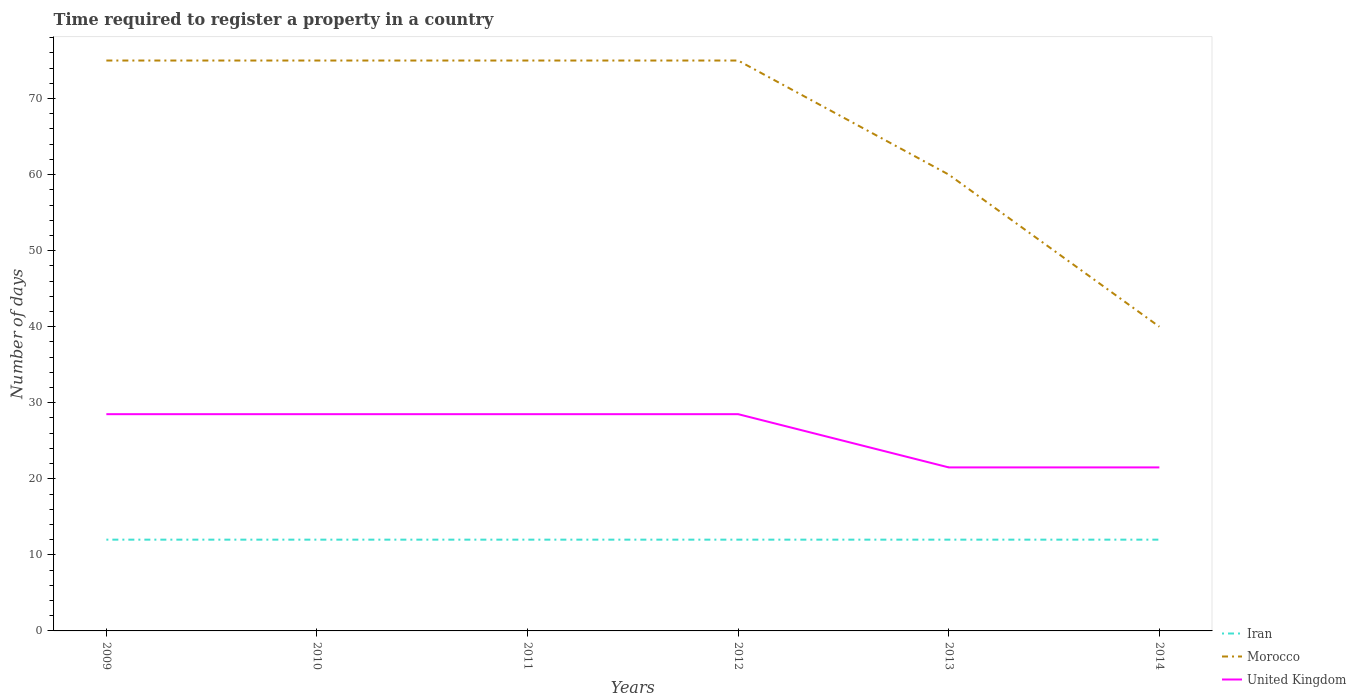How many different coloured lines are there?
Your answer should be compact. 3. Does the line corresponding to Iran intersect with the line corresponding to United Kingdom?
Ensure brevity in your answer.  No. Is the number of lines equal to the number of legend labels?
Your response must be concise. Yes. Across all years, what is the maximum number of days required to register a property in United Kingdom?
Keep it short and to the point. 21.5. In which year was the number of days required to register a property in Iran maximum?
Keep it short and to the point. 2009. What is the difference between the highest and the second highest number of days required to register a property in Morocco?
Offer a very short reply. 35. What is the difference between the highest and the lowest number of days required to register a property in Iran?
Offer a terse response. 0. How many years are there in the graph?
Your answer should be compact. 6. What is the difference between two consecutive major ticks on the Y-axis?
Make the answer very short. 10. Are the values on the major ticks of Y-axis written in scientific E-notation?
Offer a very short reply. No. Does the graph contain any zero values?
Keep it short and to the point. No. Does the graph contain grids?
Provide a short and direct response. No. What is the title of the graph?
Provide a succinct answer. Time required to register a property in a country. Does "Somalia" appear as one of the legend labels in the graph?
Offer a very short reply. No. What is the label or title of the X-axis?
Keep it short and to the point. Years. What is the label or title of the Y-axis?
Keep it short and to the point. Number of days. What is the Number of days in Morocco in 2009?
Your answer should be compact. 75. What is the Number of days in United Kingdom in 2009?
Your response must be concise. 28.5. What is the Number of days of Iran in 2010?
Make the answer very short. 12. What is the Number of days in Morocco in 2010?
Give a very brief answer. 75. What is the Number of days in United Kingdom in 2010?
Give a very brief answer. 28.5. What is the Number of days of United Kingdom in 2011?
Your response must be concise. 28.5. What is the Number of days of Iran in 2012?
Make the answer very short. 12. What is the Number of days in Morocco in 2012?
Your response must be concise. 75. What is the Number of days of Iran in 2013?
Your response must be concise. 12. What is the Number of days of United Kingdom in 2013?
Give a very brief answer. 21.5. Across all years, what is the maximum Number of days of Iran?
Keep it short and to the point. 12. What is the total Number of days of Iran in the graph?
Your answer should be very brief. 72. What is the total Number of days in Morocco in the graph?
Your answer should be very brief. 400. What is the total Number of days in United Kingdom in the graph?
Keep it short and to the point. 157. What is the difference between the Number of days in Iran in 2009 and that in 2010?
Your response must be concise. 0. What is the difference between the Number of days of United Kingdom in 2009 and that in 2010?
Offer a terse response. 0. What is the difference between the Number of days of Morocco in 2009 and that in 2011?
Give a very brief answer. 0. What is the difference between the Number of days in Morocco in 2009 and that in 2012?
Give a very brief answer. 0. What is the difference between the Number of days of Morocco in 2009 and that in 2013?
Ensure brevity in your answer.  15. What is the difference between the Number of days in Iran in 2009 and that in 2014?
Provide a short and direct response. 0. What is the difference between the Number of days in Morocco in 2009 and that in 2014?
Offer a terse response. 35. What is the difference between the Number of days in United Kingdom in 2009 and that in 2014?
Keep it short and to the point. 7. What is the difference between the Number of days in United Kingdom in 2010 and that in 2011?
Ensure brevity in your answer.  0. What is the difference between the Number of days in Iran in 2010 and that in 2012?
Offer a terse response. 0. What is the difference between the Number of days of Morocco in 2010 and that in 2012?
Provide a succinct answer. 0. What is the difference between the Number of days in United Kingdom in 2010 and that in 2014?
Offer a very short reply. 7. What is the difference between the Number of days of Morocco in 2011 and that in 2012?
Make the answer very short. 0. What is the difference between the Number of days in Iran in 2011 and that in 2013?
Your response must be concise. 0. What is the difference between the Number of days of Morocco in 2011 and that in 2014?
Provide a short and direct response. 35. What is the difference between the Number of days of United Kingdom in 2011 and that in 2014?
Offer a very short reply. 7. What is the difference between the Number of days of Morocco in 2012 and that in 2013?
Offer a terse response. 15. What is the difference between the Number of days in United Kingdom in 2012 and that in 2013?
Give a very brief answer. 7. What is the difference between the Number of days of Iran in 2012 and that in 2014?
Give a very brief answer. 0. What is the difference between the Number of days in Morocco in 2012 and that in 2014?
Your response must be concise. 35. What is the difference between the Number of days in United Kingdom in 2012 and that in 2014?
Your answer should be compact. 7. What is the difference between the Number of days of United Kingdom in 2013 and that in 2014?
Offer a terse response. 0. What is the difference between the Number of days of Iran in 2009 and the Number of days of Morocco in 2010?
Make the answer very short. -63. What is the difference between the Number of days of Iran in 2009 and the Number of days of United Kingdom in 2010?
Ensure brevity in your answer.  -16.5. What is the difference between the Number of days in Morocco in 2009 and the Number of days in United Kingdom in 2010?
Your response must be concise. 46.5. What is the difference between the Number of days in Iran in 2009 and the Number of days in Morocco in 2011?
Make the answer very short. -63. What is the difference between the Number of days in Iran in 2009 and the Number of days in United Kingdom in 2011?
Ensure brevity in your answer.  -16.5. What is the difference between the Number of days in Morocco in 2009 and the Number of days in United Kingdom in 2011?
Your answer should be very brief. 46.5. What is the difference between the Number of days of Iran in 2009 and the Number of days of Morocco in 2012?
Ensure brevity in your answer.  -63. What is the difference between the Number of days in Iran in 2009 and the Number of days in United Kingdom in 2012?
Provide a short and direct response. -16.5. What is the difference between the Number of days of Morocco in 2009 and the Number of days of United Kingdom in 2012?
Your answer should be very brief. 46.5. What is the difference between the Number of days of Iran in 2009 and the Number of days of Morocco in 2013?
Your response must be concise. -48. What is the difference between the Number of days of Morocco in 2009 and the Number of days of United Kingdom in 2013?
Keep it short and to the point. 53.5. What is the difference between the Number of days in Morocco in 2009 and the Number of days in United Kingdom in 2014?
Keep it short and to the point. 53.5. What is the difference between the Number of days in Iran in 2010 and the Number of days in Morocco in 2011?
Your response must be concise. -63. What is the difference between the Number of days of Iran in 2010 and the Number of days of United Kingdom in 2011?
Your response must be concise. -16.5. What is the difference between the Number of days in Morocco in 2010 and the Number of days in United Kingdom in 2011?
Make the answer very short. 46.5. What is the difference between the Number of days in Iran in 2010 and the Number of days in Morocco in 2012?
Give a very brief answer. -63. What is the difference between the Number of days of Iran in 2010 and the Number of days of United Kingdom in 2012?
Give a very brief answer. -16.5. What is the difference between the Number of days in Morocco in 2010 and the Number of days in United Kingdom in 2012?
Provide a succinct answer. 46.5. What is the difference between the Number of days of Iran in 2010 and the Number of days of Morocco in 2013?
Offer a very short reply. -48. What is the difference between the Number of days of Iran in 2010 and the Number of days of United Kingdom in 2013?
Provide a succinct answer. -9.5. What is the difference between the Number of days of Morocco in 2010 and the Number of days of United Kingdom in 2013?
Your answer should be very brief. 53.5. What is the difference between the Number of days in Morocco in 2010 and the Number of days in United Kingdom in 2014?
Your answer should be very brief. 53.5. What is the difference between the Number of days in Iran in 2011 and the Number of days in Morocco in 2012?
Keep it short and to the point. -63. What is the difference between the Number of days in Iran in 2011 and the Number of days in United Kingdom in 2012?
Keep it short and to the point. -16.5. What is the difference between the Number of days of Morocco in 2011 and the Number of days of United Kingdom in 2012?
Make the answer very short. 46.5. What is the difference between the Number of days of Iran in 2011 and the Number of days of Morocco in 2013?
Offer a terse response. -48. What is the difference between the Number of days of Iran in 2011 and the Number of days of United Kingdom in 2013?
Make the answer very short. -9.5. What is the difference between the Number of days in Morocco in 2011 and the Number of days in United Kingdom in 2013?
Provide a short and direct response. 53.5. What is the difference between the Number of days in Morocco in 2011 and the Number of days in United Kingdom in 2014?
Provide a succinct answer. 53.5. What is the difference between the Number of days in Iran in 2012 and the Number of days in Morocco in 2013?
Ensure brevity in your answer.  -48. What is the difference between the Number of days in Iran in 2012 and the Number of days in United Kingdom in 2013?
Ensure brevity in your answer.  -9.5. What is the difference between the Number of days of Morocco in 2012 and the Number of days of United Kingdom in 2013?
Ensure brevity in your answer.  53.5. What is the difference between the Number of days in Morocco in 2012 and the Number of days in United Kingdom in 2014?
Provide a succinct answer. 53.5. What is the difference between the Number of days in Iran in 2013 and the Number of days in Morocco in 2014?
Your response must be concise. -28. What is the difference between the Number of days in Iran in 2013 and the Number of days in United Kingdom in 2014?
Provide a short and direct response. -9.5. What is the difference between the Number of days in Morocco in 2013 and the Number of days in United Kingdom in 2014?
Your answer should be very brief. 38.5. What is the average Number of days of Iran per year?
Ensure brevity in your answer.  12. What is the average Number of days of Morocco per year?
Provide a succinct answer. 66.67. What is the average Number of days of United Kingdom per year?
Your answer should be very brief. 26.17. In the year 2009, what is the difference between the Number of days in Iran and Number of days in Morocco?
Your response must be concise. -63. In the year 2009, what is the difference between the Number of days in Iran and Number of days in United Kingdom?
Keep it short and to the point. -16.5. In the year 2009, what is the difference between the Number of days of Morocco and Number of days of United Kingdom?
Give a very brief answer. 46.5. In the year 2010, what is the difference between the Number of days in Iran and Number of days in Morocco?
Make the answer very short. -63. In the year 2010, what is the difference between the Number of days in Iran and Number of days in United Kingdom?
Offer a terse response. -16.5. In the year 2010, what is the difference between the Number of days of Morocco and Number of days of United Kingdom?
Offer a terse response. 46.5. In the year 2011, what is the difference between the Number of days in Iran and Number of days in Morocco?
Make the answer very short. -63. In the year 2011, what is the difference between the Number of days in Iran and Number of days in United Kingdom?
Your answer should be compact. -16.5. In the year 2011, what is the difference between the Number of days in Morocco and Number of days in United Kingdom?
Your response must be concise. 46.5. In the year 2012, what is the difference between the Number of days in Iran and Number of days in Morocco?
Ensure brevity in your answer.  -63. In the year 2012, what is the difference between the Number of days of Iran and Number of days of United Kingdom?
Provide a short and direct response. -16.5. In the year 2012, what is the difference between the Number of days of Morocco and Number of days of United Kingdom?
Provide a short and direct response. 46.5. In the year 2013, what is the difference between the Number of days of Iran and Number of days of Morocco?
Ensure brevity in your answer.  -48. In the year 2013, what is the difference between the Number of days of Morocco and Number of days of United Kingdom?
Your response must be concise. 38.5. In the year 2014, what is the difference between the Number of days in Iran and Number of days in United Kingdom?
Keep it short and to the point. -9.5. What is the ratio of the Number of days in Iran in 2009 to that in 2010?
Offer a very short reply. 1. What is the ratio of the Number of days in Iran in 2009 to that in 2011?
Provide a short and direct response. 1. What is the ratio of the Number of days of Morocco in 2009 to that in 2011?
Your answer should be very brief. 1. What is the ratio of the Number of days in United Kingdom in 2009 to that in 2011?
Offer a very short reply. 1. What is the ratio of the Number of days of United Kingdom in 2009 to that in 2012?
Provide a succinct answer. 1. What is the ratio of the Number of days of Morocco in 2009 to that in 2013?
Ensure brevity in your answer.  1.25. What is the ratio of the Number of days of United Kingdom in 2009 to that in 2013?
Offer a terse response. 1.33. What is the ratio of the Number of days of Morocco in 2009 to that in 2014?
Offer a very short reply. 1.88. What is the ratio of the Number of days in United Kingdom in 2009 to that in 2014?
Your answer should be compact. 1.33. What is the ratio of the Number of days in Iran in 2010 to that in 2011?
Your answer should be very brief. 1. What is the ratio of the Number of days in Morocco in 2010 to that in 2011?
Your answer should be compact. 1. What is the ratio of the Number of days of Iran in 2010 to that in 2012?
Ensure brevity in your answer.  1. What is the ratio of the Number of days in United Kingdom in 2010 to that in 2013?
Offer a terse response. 1.33. What is the ratio of the Number of days of Morocco in 2010 to that in 2014?
Your response must be concise. 1.88. What is the ratio of the Number of days in United Kingdom in 2010 to that in 2014?
Your answer should be compact. 1.33. What is the ratio of the Number of days in Iran in 2011 to that in 2012?
Keep it short and to the point. 1. What is the ratio of the Number of days in Morocco in 2011 to that in 2012?
Your response must be concise. 1. What is the ratio of the Number of days of United Kingdom in 2011 to that in 2013?
Give a very brief answer. 1.33. What is the ratio of the Number of days of Iran in 2011 to that in 2014?
Ensure brevity in your answer.  1. What is the ratio of the Number of days in Morocco in 2011 to that in 2014?
Offer a terse response. 1.88. What is the ratio of the Number of days of United Kingdom in 2011 to that in 2014?
Your answer should be compact. 1.33. What is the ratio of the Number of days of United Kingdom in 2012 to that in 2013?
Provide a short and direct response. 1.33. What is the ratio of the Number of days in Morocco in 2012 to that in 2014?
Offer a very short reply. 1.88. What is the ratio of the Number of days in United Kingdom in 2012 to that in 2014?
Give a very brief answer. 1.33. What is the ratio of the Number of days of Iran in 2013 to that in 2014?
Your answer should be very brief. 1. What is the ratio of the Number of days of Morocco in 2013 to that in 2014?
Offer a terse response. 1.5. What is the ratio of the Number of days of United Kingdom in 2013 to that in 2014?
Your answer should be compact. 1. What is the difference between the highest and the lowest Number of days of Iran?
Give a very brief answer. 0. 